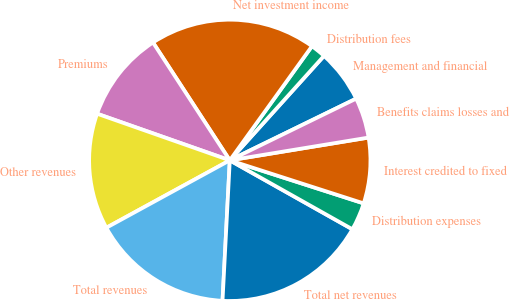<chart> <loc_0><loc_0><loc_500><loc_500><pie_chart><fcel>Management and financial<fcel>Distribution fees<fcel>Net investment income<fcel>Premiums<fcel>Other revenues<fcel>Total revenues<fcel>Total net revenues<fcel>Distribution expenses<fcel>Interest credited to fixed<fcel>Benefits claims losses and<nl><fcel>6.09%<fcel>1.75%<fcel>19.12%<fcel>10.43%<fcel>13.33%<fcel>16.22%<fcel>17.67%<fcel>3.2%<fcel>7.54%<fcel>4.64%<nl></chart> 